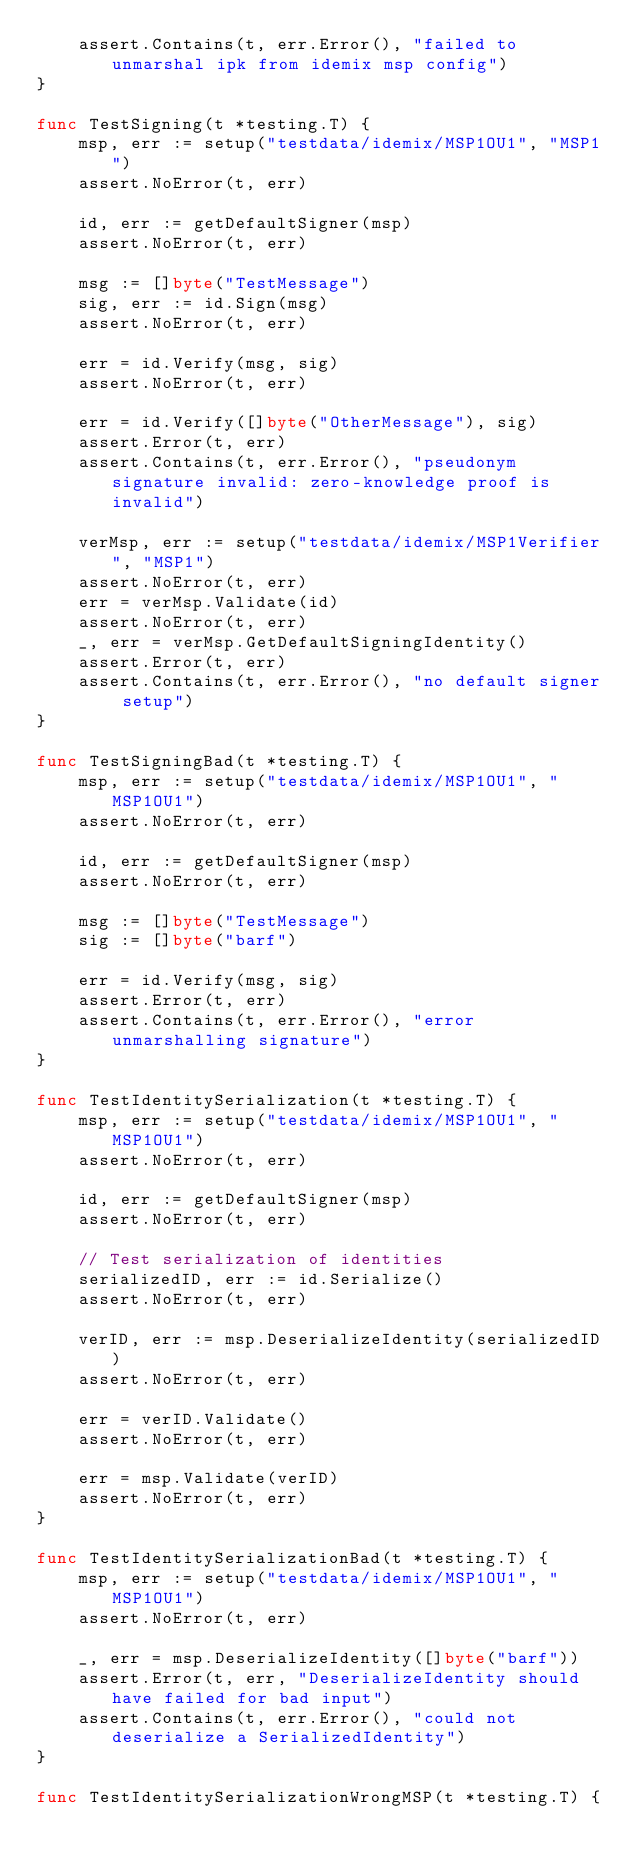Convert code to text. <code><loc_0><loc_0><loc_500><loc_500><_Go_>	assert.Contains(t, err.Error(), "failed to unmarshal ipk from idemix msp config")
}

func TestSigning(t *testing.T) {
	msp, err := setup("testdata/idemix/MSP1OU1", "MSP1")
	assert.NoError(t, err)

	id, err := getDefaultSigner(msp)
	assert.NoError(t, err)

	msg := []byte("TestMessage")
	sig, err := id.Sign(msg)
	assert.NoError(t, err)

	err = id.Verify(msg, sig)
	assert.NoError(t, err)

	err = id.Verify([]byte("OtherMessage"), sig)
	assert.Error(t, err)
	assert.Contains(t, err.Error(), "pseudonym signature invalid: zero-knowledge proof is invalid")

	verMsp, err := setup("testdata/idemix/MSP1Verifier", "MSP1")
	assert.NoError(t, err)
	err = verMsp.Validate(id)
	assert.NoError(t, err)
	_, err = verMsp.GetDefaultSigningIdentity()
	assert.Error(t, err)
	assert.Contains(t, err.Error(), "no default signer setup")
}

func TestSigningBad(t *testing.T) {
	msp, err := setup("testdata/idemix/MSP1OU1", "MSP1OU1")
	assert.NoError(t, err)

	id, err := getDefaultSigner(msp)
	assert.NoError(t, err)

	msg := []byte("TestMessage")
	sig := []byte("barf")

	err = id.Verify(msg, sig)
	assert.Error(t, err)
	assert.Contains(t, err.Error(), "error unmarshalling signature")
}

func TestIdentitySerialization(t *testing.T) {
	msp, err := setup("testdata/idemix/MSP1OU1", "MSP1OU1")
	assert.NoError(t, err)

	id, err := getDefaultSigner(msp)
	assert.NoError(t, err)

	// Test serialization of identities
	serializedID, err := id.Serialize()
	assert.NoError(t, err)

	verID, err := msp.DeserializeIdentity(serializedID)
	assert.NoError(t, err)

	err = verID.Validate()
	assert.NoError(t, err)

	err = msp.Validate(verID)
	assert.NoError(t, err)
}

func TestIdentitySerializationBad(t *testing.T) {
	msp, err := setup("testdata/idemix/MSP1OU1", "MSP1OU1")
	assert.NoError(t, err)

	_, err = msp.DeserializeIdentity([]byte("barf"))
	assert.Error(t, err, "DeserializeIdentity should have failed for bad input")
	assert.Contains(t, err.Error(), "could not deserialize a SerializedIdentity")
}

func TestIdentitySerializationWrongMSP(t *testing.T) {</code> 